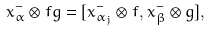<formula> <loc_0><loc_0><loc_500><loc_500>x ^ { - } _ { \alpha } \otimes f g = [ x ^ { - } _ { \alpha _ { j } } \otimes f , x ^ { - } _ { \beta } \otimes g ] ,</formula> 